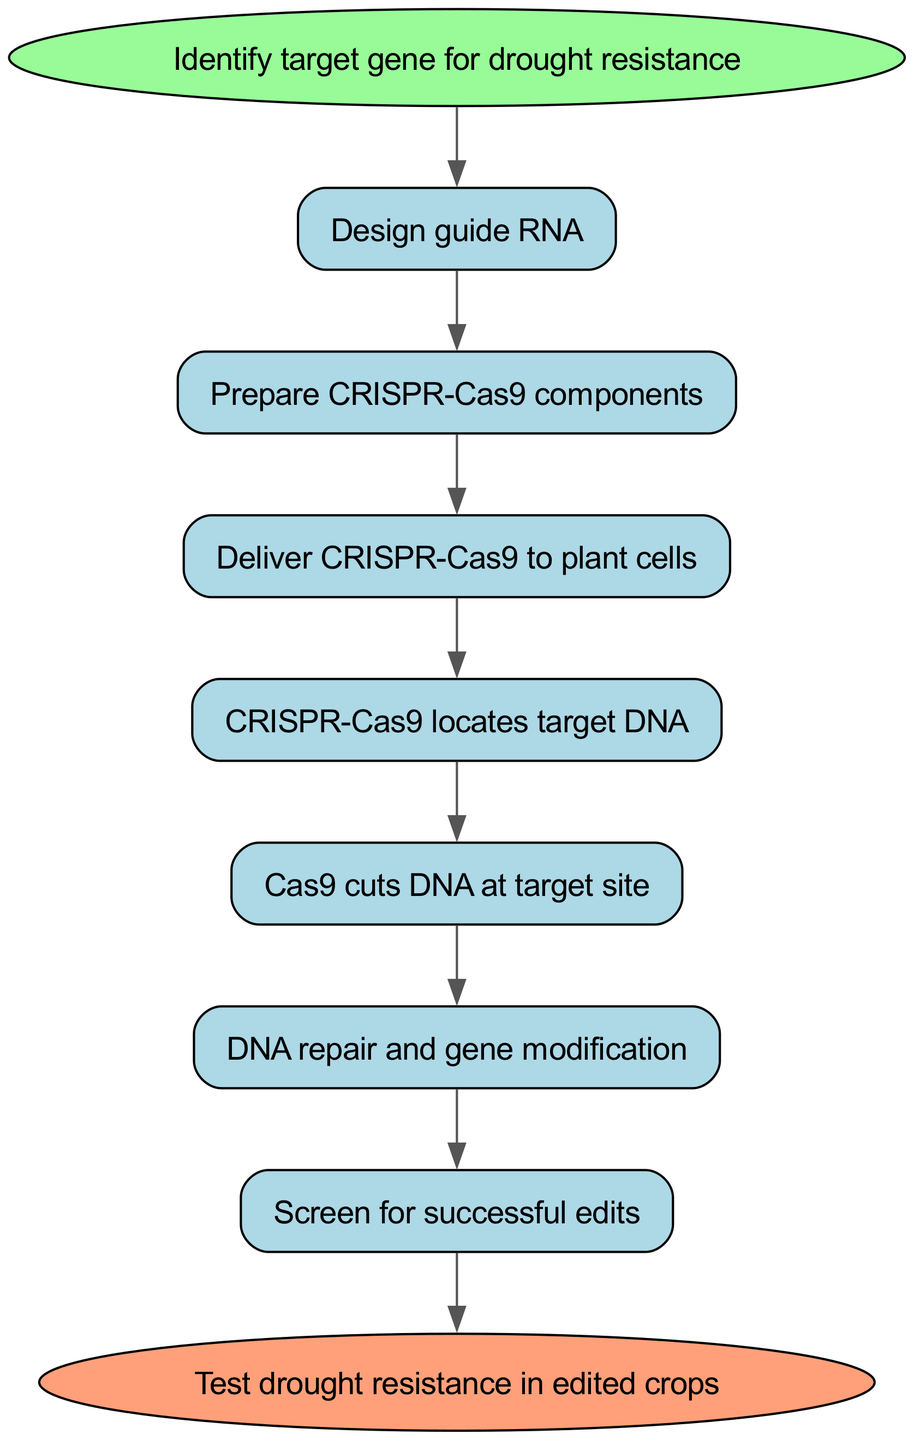What is the starting point of the process? According to the diagram, the starting point of the process is labeled as "Identify target gene for drought resistance." This node is the first step in the flow.
Answer: Identify target gene for drought resistance How many steps are there in the gene editing process? The diagram consists of six main steps outlined between the starting and ending points. These steps include designing guide RNA, preparing components, delivering to plant cells, locating target DNA, cutting DNA, and modifying gene.
Answer: Six What is the last step before testing drought resistance? The last step in the process before testing drought resistance is "Propagate edited plants." This is the final action taken right before the testing phase begins.
Answer: Propagate edited plants Which step comes after "Cas9 cuts DNA at target site"? The step that follows "Cas9 cuts DNA at target site" is "DNA repair and gene modification." This demonstrates the sequence in which the events occur in the flow of the diagram.
Answer: DNA repair and gene modification What color represents the end of the process? The end node is colored in soft pink, specifically represented as "#FFA07A" in the diagram. This unique coloring distinguishes it from other nodes.
Answer: Pink If "Screen for successful edits" is successful, what is the next action? If "Screen for successful edits" is successful, the next action is "Propagate edited plants." This shows a clear progression from editing verification to further cultivation steps.
Answer: Propagate edited plants What is the relationship between "Deliver CRISPR-Cas9 to plant cells" and "CRISPR-Cas9 locates target DNA"? The relationship is sequential; "Deliver CRISPR-Cas9 to plant cells" must occur first before "CRISPR-Cas9 locates target DNA." This indicates a necessary order in the gene editing process.
Answer: Sequential Which process step involves gene modification? The step referred to as "DNA repair and gene modification" encompasses the actual gene modification part of the CRISPR-Cas9 process.
Answer: DNA repair and gene modification What operation is represented between "Design guide RNA" and "Prepare CRISPR-Cas9 components"? The operation represented is a progression; "Prepare CRISPR-Cas9 components" is the action taken immediately following "Design guide RNA." This encapsulates a necessary step in the sequence of the editing process.
Answer: Progression 